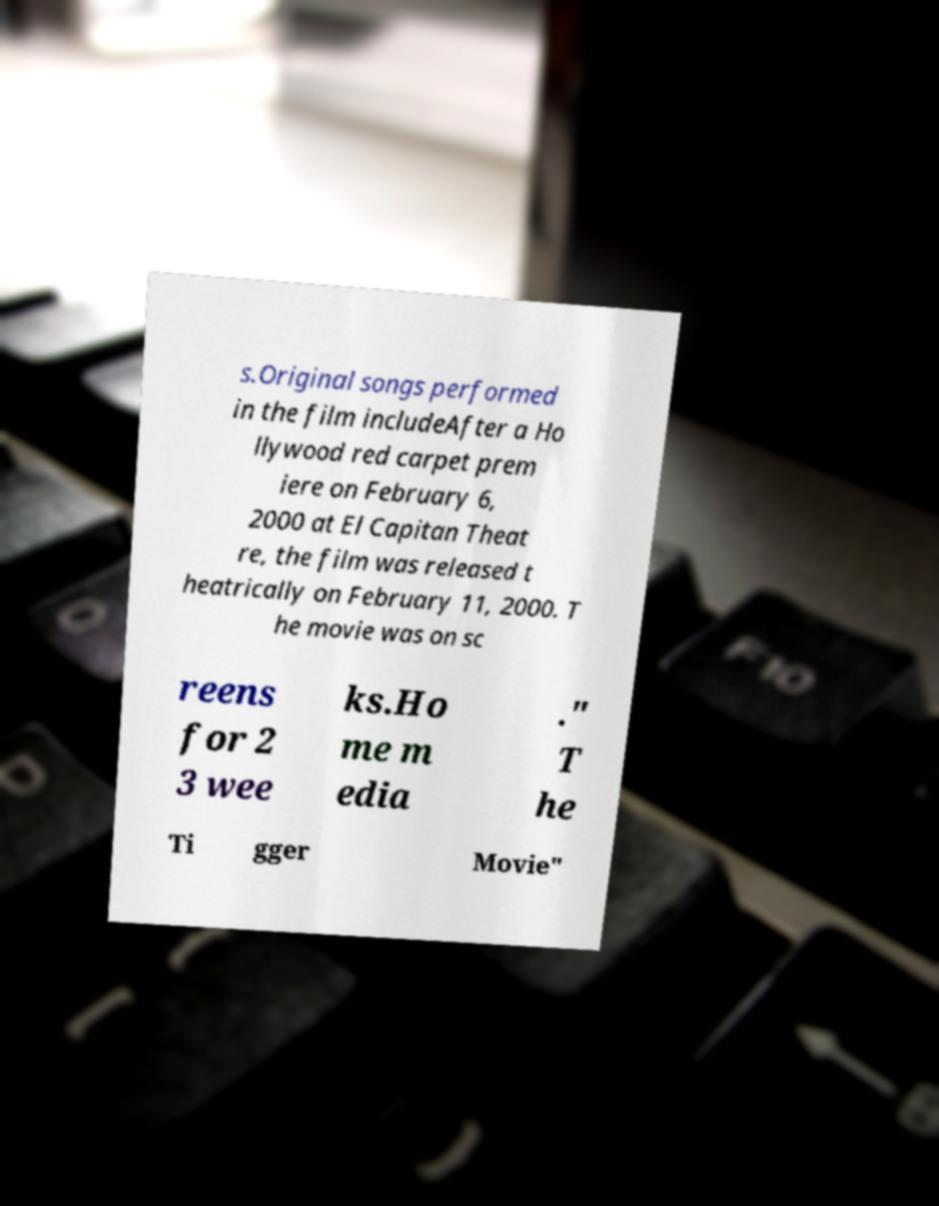Please read and relay the text visible in this image. What does it say? s.Original songs performed in the film includeAfter a Ho llywood red carpet prem iere on February 6, 2000 at El Capitan Theat re, the film was released t heatrically on February 11, 2000. T he movie was on sc reens for 2 3 wee ks.Ho me m edia ." T he Ti gger Movie" 